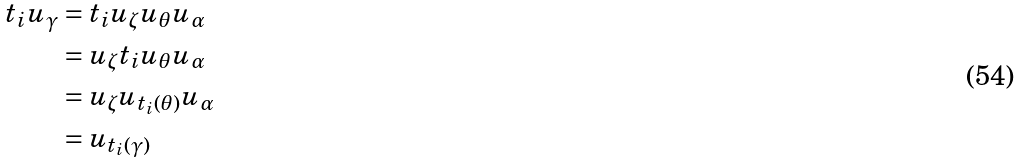<formula> <loc_0><loc_0><loc_500><loc_500>t _ { i } u _ { \gamma } & = t _ { i } u _ { \zeta } u _ { \theta } u _ { \alpha } \\ & = u _ { \zeta } t _ { i } u _ { \theta } u _ { \alpha } \\ & = u _ { \zeta } u _ { t _ { i } ( \theta ) } u _ { \alpha } \\ & = u _ { t _ { i } ( \gamma ) }</formula> 